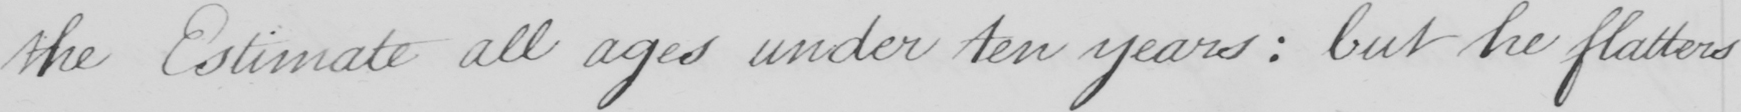Please transcribe the handwritten text in this image. the Estimate all ages under ten years :  but he flatters 